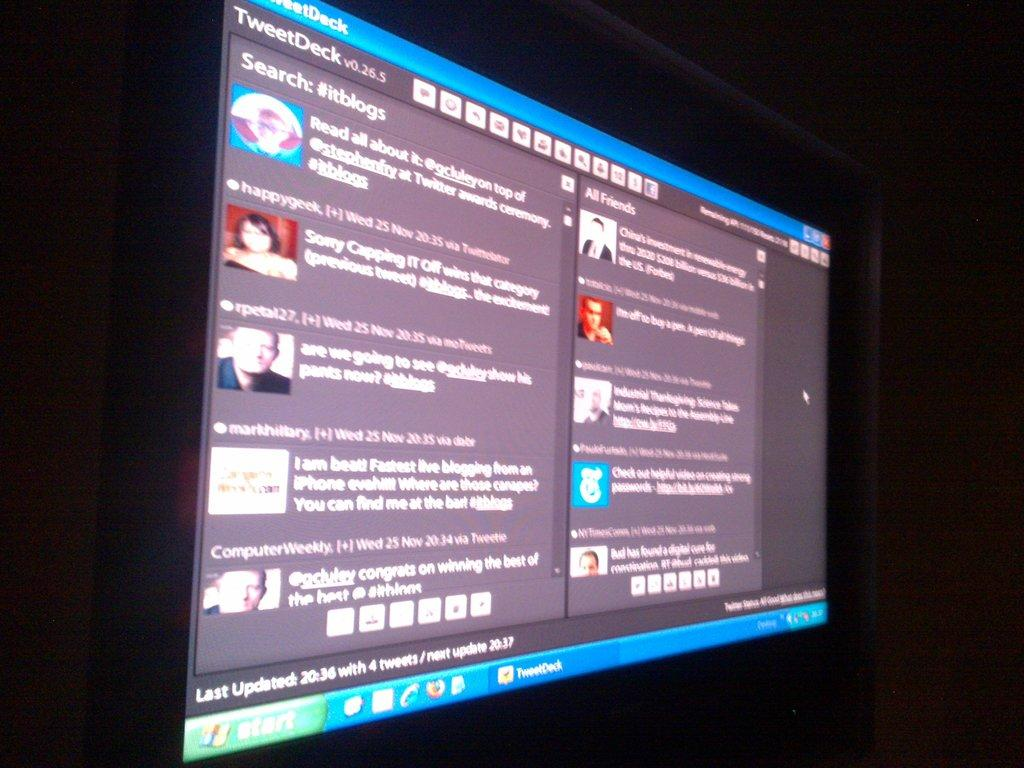<image>
Describe the image concisely. A computer screen showing descriptions of different tweets. 